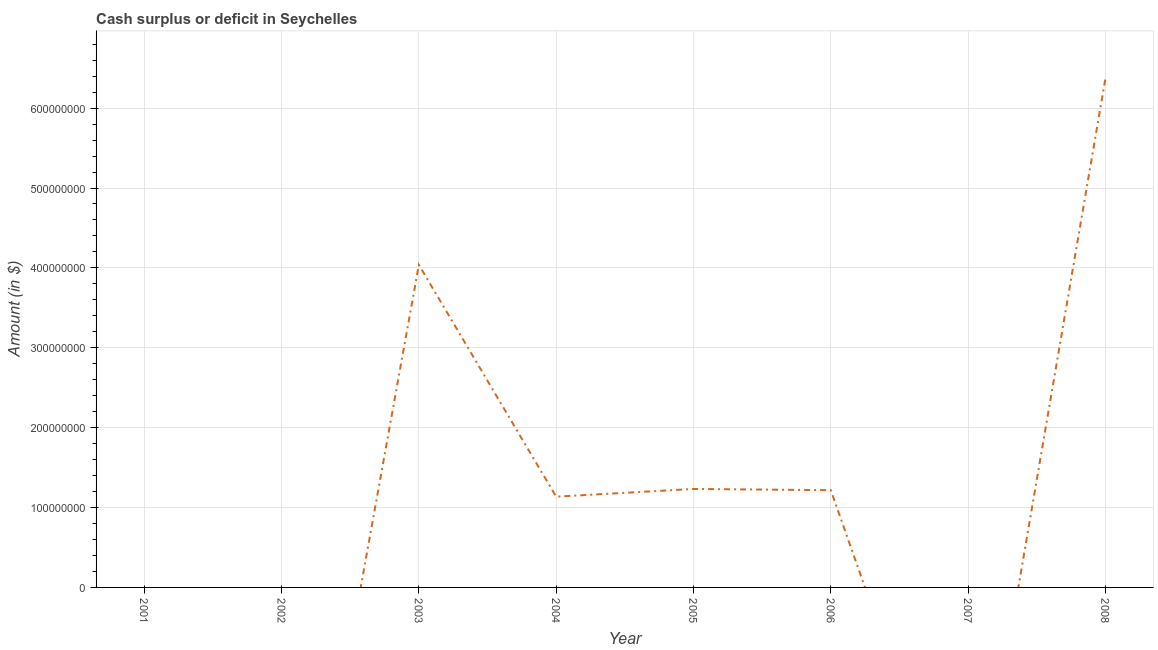What is the cash surplus or deficit in 2008?
Your response must be concise. 6.37e+08. Across all years, what is the maximum cash surplus or deficit?
Keep it short and to the point. 6.37e+08. Across all years, what is the minimum cash surplus or deficit?
Keep it short and to the point. 0. In which year was the cash surplus or deficit maximum?
Keep it short and to the point. 2008. What is the sum of the cash surplus or deficit?
Provide a short and direct response. 1.40e+09. What is the difference between the cash surplus or deficit in 2003 and 2004?
Your response must be concise. 2.90e+08. What is the average cash surplus or deficit per year?
Provide a short and direct response. 1.75e+08. What is the median cash surplus or deficit?
Provide a succinct answer. 1.18e+08. What is the ratio of the cash surplus or deficit in 2004 to that in 2005?
Make the answer very short. 0.92. What is the difference between the highest and the second highest cash surplus or deficit?
Provide a short and direct response. 2.34e+08. What is the difference between the highest and the lowest cash surplus or deficit?
Offer a terse response. 6.37e+08. In how many years, is the cash surplus or deficit greater than the average cash surplus or deficit taken over all years?
Your answer should be very brief. 2. Does the cash surplus or deficit monotonically increase over the years?
Offer a very short reply. No. How many lines are there?
Provide a succinct answer. 1. Are the values on the major ticks of Y-axis written in scientific E-notation?
Ensure brevity in your answer.  No. Does the graph contain any zero values?
Your response must be concise. Yes. Does the graph contain grids?
Your answer should be compact. Yes. What is the title of the graph?
Give a very brief answer. Cash surplus or deficit in Seychelles. What is the label or title of the X-axis?
Give a very brief answer. Year. What is the label or title of the Y-axis?
Offer a terse response. Amount (in $). What is the Amount (in $) in 2003?
Provide a short and direct response. 4.04e+08. What is the Amount (in $) in 2004?
Offer a terse response. 1.14e+08. What is the Amount (in $) in 2005?
Keep it short and to the point. 1.23e+08. What is the Amount (in $) of 2006?
Your response must be concise. 1.22e+08. What is the Amount (in $) of 2007?
Offer a very short reply. 0. What is the Amount (in $) in 2008?
Keep it short and to the point. 6.37e+08. What is the difference between the Amount (in $) in 2003 and 2004?
Offer a terse response. 2.90e+08. What is the difference between the Amount (in $) in 2003 and 2005?
Your answer should be very brief. 2.81e+08. What is the difference between the Amount (in $) in 2003 and 2006?
Offer a terse response. 2.82e+08. What is the difference between the Amount (in $) in 2003 and 2008?
Offer a very short reply. -2.34e+08. What is the difference between the Amount (in $) in 2004 and 2005?
Make the answer very short. -9.68e+06. What is the difference between the Amount (in $) in 2004 and 2006?
Offer a terse response. -8.13e+06. What is the difference between the Amount (in $) in 2004 and 2008?
Provide a succinct answer. -5.24e+08. What is the difference between the Amount (in $) in 2005 and 2006?
Your answer should be very brief. 1.55e+06. What is the difference between the Amount (in $) in 2005 and 2008?
Give a very brief answer. -5.14e+08. What is the difference between the Amount (in $) in 2006 and 2008?
Provide a succinct answer. -5.16e+08. What is the ratio of the Amount (in $) in 2003 to that in 2004?
Keep it short and to the point. 3.56. What is the ratio of the Amount (in $) in 2003 to that in 2005?
Offer a very short reply. 3.28. What is the ratio of the Amount (in $) in 2003 to that in 2006?
Make the answer very short. 3.32. What is the ratio of the Amount (in $) in 2003 to that in 2008?
Make the answer very short. 0.63. What is the ratio of the Amount (in $) in 2004 to that in 2005?
Offer a terse response. 0.92. What is the ratio of the Amount (in $) in 2004 to that in 2006?
Ensure brevity in your answer.  0.93. What is the ratio of the Amount (in $) in 2004 to that in 2008?
Give a very brief answer. 0.18. What is the ratio of the Amount (in $) in 2005 to that in 2006?
Provide a short and direct response. 1.01. What is the ratio of the Amount (in $) in 2005 to that in 2008?
Your answer should be very brief. 0.19. What is the ratio of the Amount (in $) in 2006 to that in 2008?
Give a very brief answer. 0.19. 